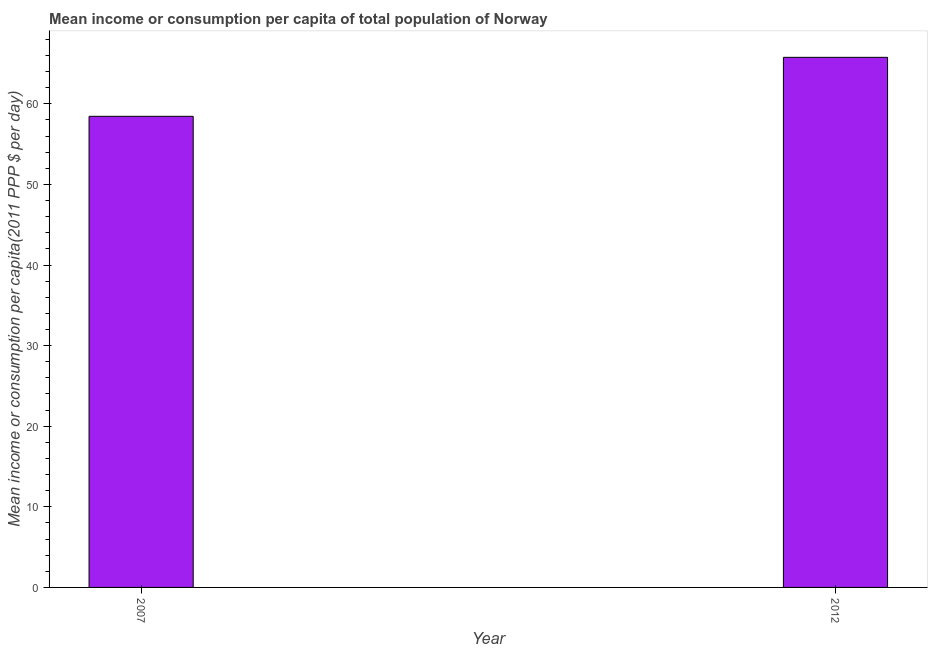What is the title of the graph?
Offer a very short reply. Mean income or consumption per capita of total population of Norway. What is the label or title of the X-axis?
Give a very brief answer. Year. What is the label or title of the Y-axis?
Your answer should be compact. Mean income or consumption per capita(2011 PPP $ per day). What is the mean income or consumption in 2007?
Give a very brief answer. 58.45. Across all years, what is the maximum mean income or consumption?
Your answer should be compact. 65.77. Across all years, what is the minimum mean income or consumption?
Give a very brief answer. 58.45. In which year was the mean income or consumption minimum?
Ensure brevity in your answer.  2007. What is the sum of the mean income or consumption?
Your response must be concise. 124.22. What is the difference between the mean income or consumption in 2007 and 2012?
Provide a short and direct response. -7.32. What is the average mean income or consumption per year?
Make the answer very short. 62.11. What is the median mean income or consumption?
Your response must be concise. 62.11. In how many years, is the mean income or consumption greater than 38 $?
Your answer should be compact. 2. Do a majority of the years between 2007 and 2012 (inclusive) have mean income or consumption greater than 22 $?
Your answer should be compact. Yes. What is the ratio of the mean income or consumption in 2007 to that in 2012?
Keep it short and to the point. 0.89. In how many years, is the mean income or consumption greater than the average mean income or consumption taken over all years?
Offer a terse response. 1. How many bars are there?
Your answer should be compact. 2. Are all the bars in the graph horizontal?
Make the answer very short. No. What is the difference between two consecutive major ticks on the Y-axis?
Provide a succinct answer. 10. What is the Mean income or consumption per capita(2011 PPP $ per day) of 2007?
Give a very brief answer. 58.45. What is the Mean income or consumption per capita(2011 PPP $ per day) in 2012?
Your response must be concise. 65.77. What is the difference between the Mean income or consumption per capita(2011 PPP $ per day) in 2007 and 2012?
Offer a terse response. -7.32. What is the ratio of the Mean income or consumption per capita(2011 PPP $ per day) in 2007 to that in 2012?
Ensure brevity in your answer.  0.89. 